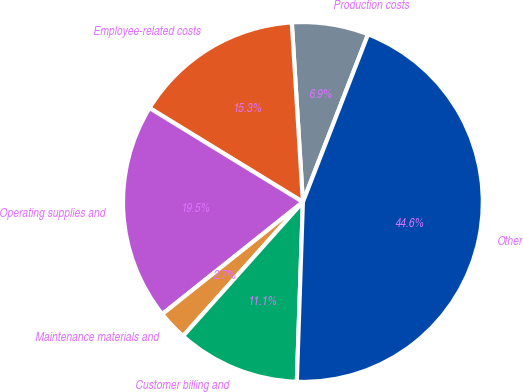Convert chart to OTSL. <chart><loc_0><loc_0><loc_500><loc_500><pie_chart><fcel>Production costs<fcel>Employee-related costs<fcel>Operating supplies and<fcel>Maintenance materials and<fcel>Customer billing and<fcel>Other<nl><fcel>6.88%<fcel>15.27%<fcel>19.46%<fcel>2.68%<fcel>11.07%<fcel>44.64%<nl></chart> 